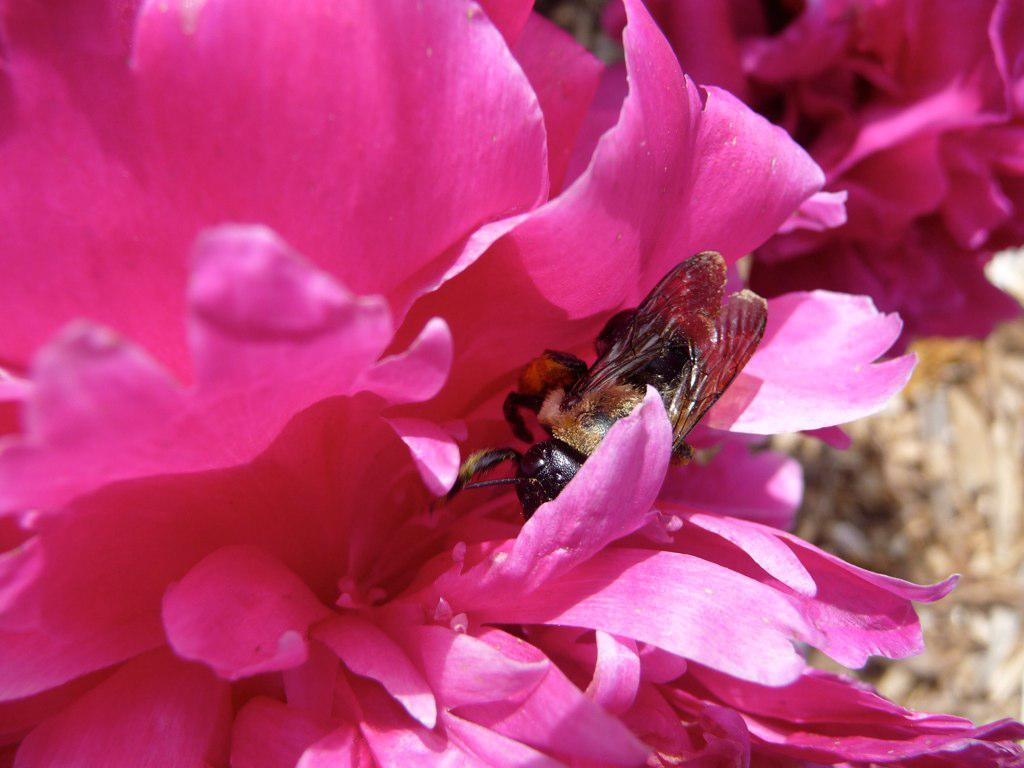What is the main subject in the foreground of the image? There is an insect on a flower in the foreground of the image. Can you describe the background of the image? There is another flower in the background of the image. What type of body is visible in the image? There is no body present in the image; it features an insect on a flower and another flower in the background. 